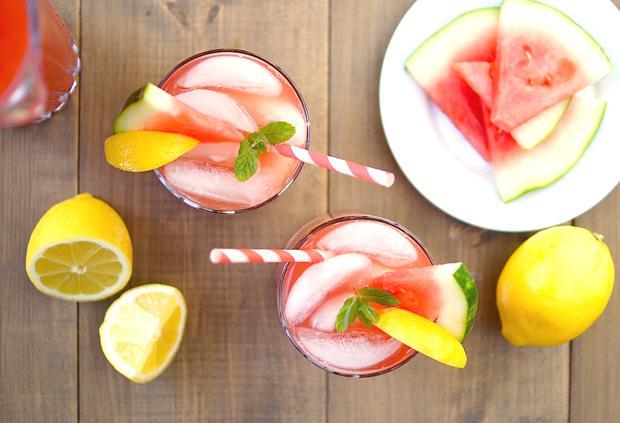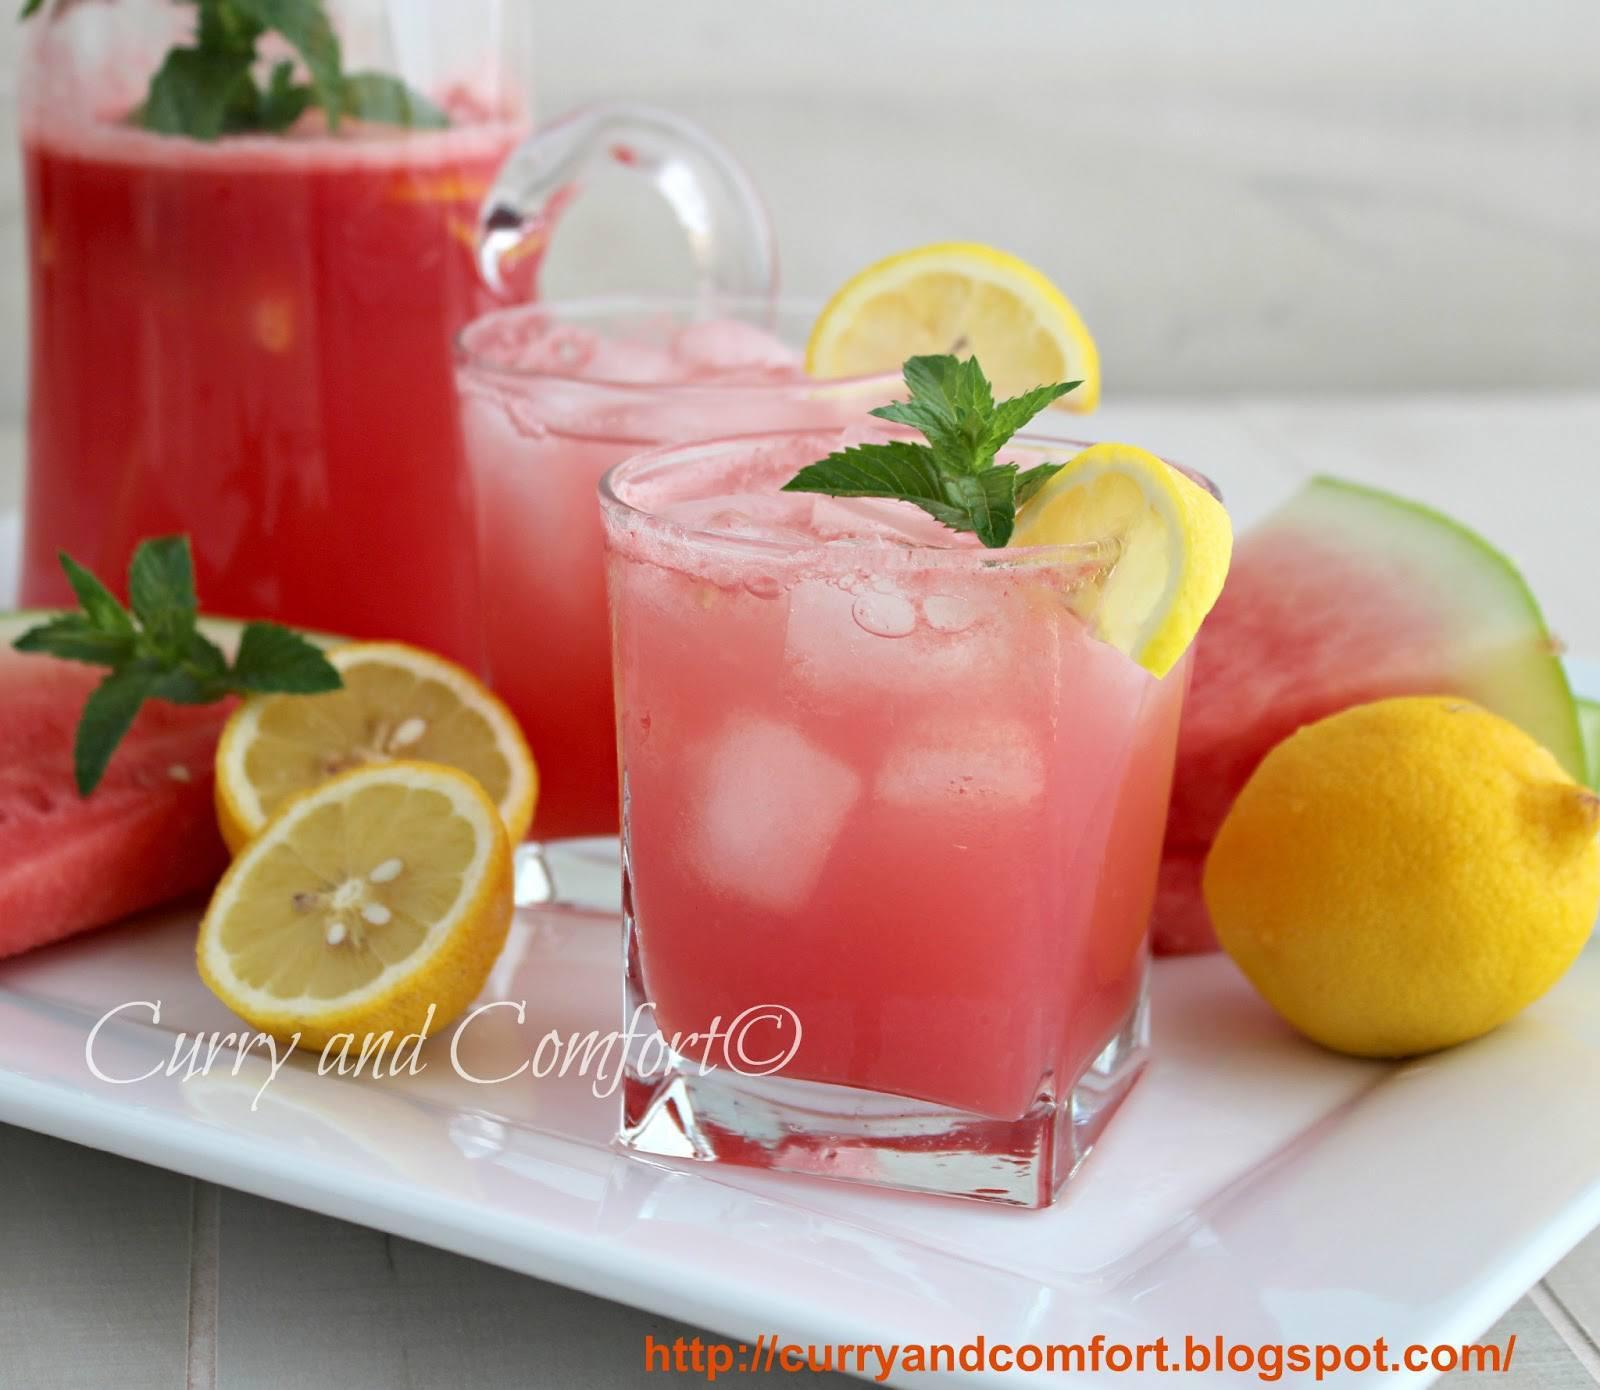The first image is the image on the left, the second image is the image on the right. For the images shown, is this caption "Left image shows glasses garnished with a thin watermelon slice." true? Answer yes or no. Yes. The first image is the image on the left, the second image is the image on the right. Examine the images to the left and right. Is the description "All drink servings are garnished with striped straws." accurate? Answer yes or no. No. 